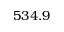Convert formula to latex. <formula><loc_0><loc_0><loc_500><loc_500>5 3 4 . 9</formula> 